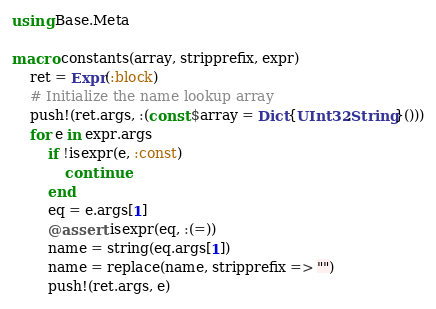<code> <loc_0><loc_0><loc_500><loc_500><_Julia_>using Base.Meta

macro constants(array, stripprefix, expr)
    ret = Expr(:block)
    # Initialize the name lookup array
    push!(ret.args, :(const $array = Dict{UInt32,String}()))
    for e in expr.args
        if !isexpr(e, :const)
            continue
        end
        eq = e.args[1]
        @assert isexpr(eq, :(=))
        name = string(eq.args[1])
        name = replace(name, stripprefix => "")
        push!(ret.args, e)</code> 